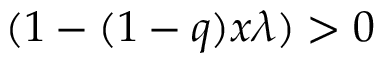Convert formula to latex. <formula><loc_0><loc_0><loc_500><loc_500>( 1 - ( 1 - q ) x \lambda ) > 0</formula> 